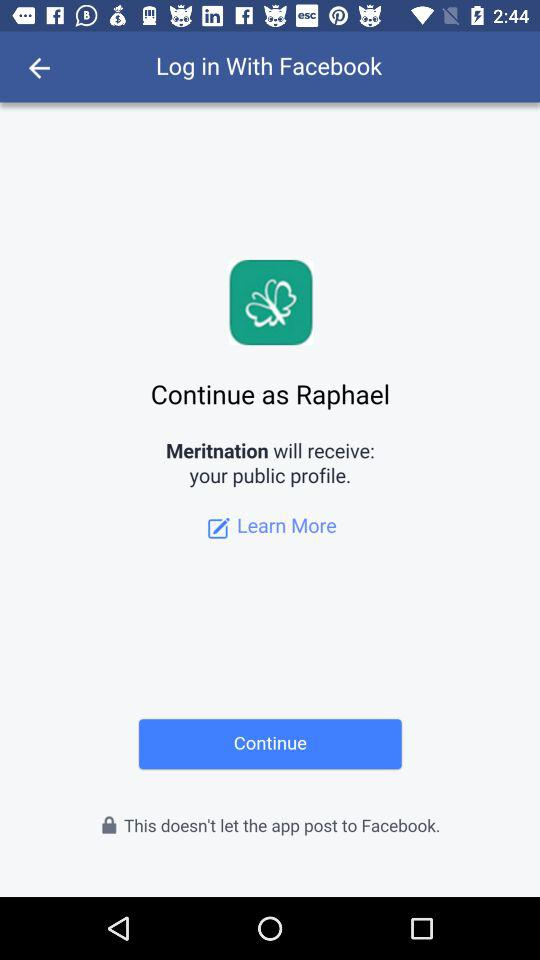Through what application can we log in? You can log in through "Facebook". 